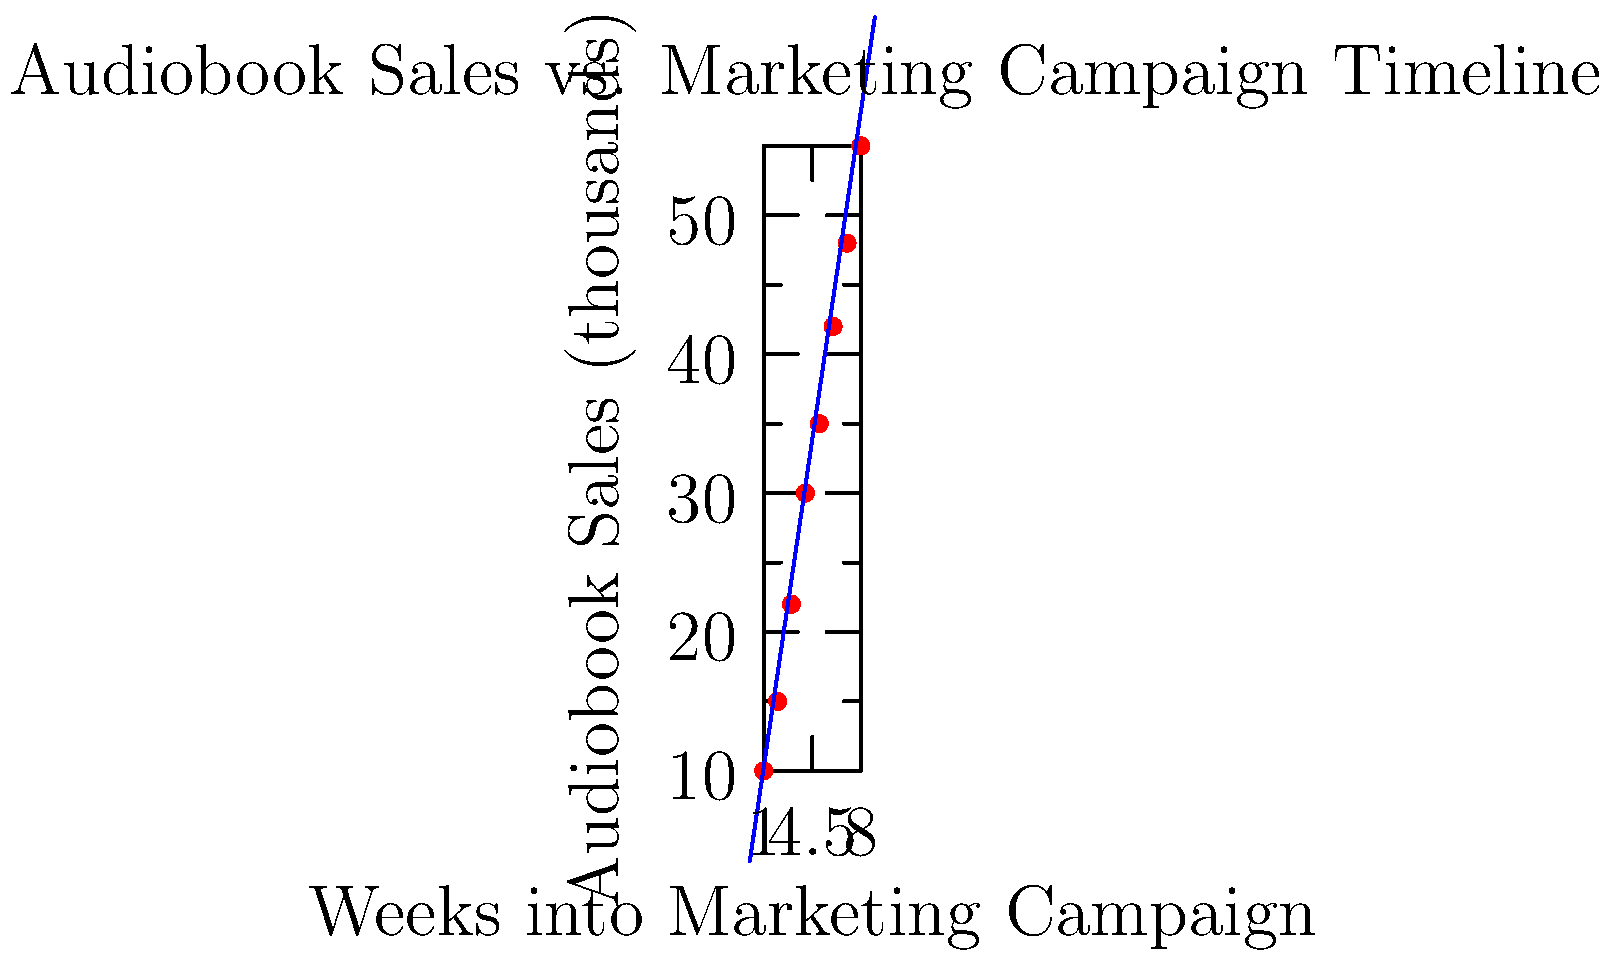Based on the scatter plot showing the relationship between audiobook sales and marketing campaign timeline, what can be inferred about the correlation between these two variables, and how might this information be used to enhance the marketability of audiobooks? To analyze the correlation between audiobook sales and marketing campaign timelines:

1. Observe the scatter plot: Points show a clear upward trend from left to right.

2. Identify the variables:
   - X-axis: Weeks into Marketing Campaign
   - Y-axis: Audiobook Sales (in thousands)

3. Assess the relationship:
   - As weeks progress, sales generally increase.
   - Points form a roughly linear pattern.
   - Positive correlation is evident.

4. Analyze the trend line:
   - Blue line represents the overall trend.
   - Slope is positive, confirming positive correlation.

5. Calculate correlation strength:
   - Use the formula: $r = \frac{\sum{(x_i - \bar{x})(y_i - \bar{y})}}{\sqrt{\sum{(x_i - \bar{x})^2}\sum{(y_i - \bar{y})^2}}}$
   - Result would be close to 1, indicating strong positive correlation.

6. Interpret for marketability:
   - Longer campaign duration correlates with higher sales.
   - Each week of campaign likely increases sales by about 6,750 units (slope of trend line).

7. Apply to marketing strategy:
   - Extend campaign duration for potentially higher sales.
   - Focus on consistent marketing efforts throughout the campaign.
   - Use sound design elements in marketing to maintain engagement over time.

8. Consider other factors:
   - Quality of marketing content
   - Target audience reach
   - Seasonal effects

This analysis provides insights for data-driven marketing decisions in audiobook promotion.
Answer: Strong positive correlation; extend marketing campaigns and use consistent, engaging sound design to potentially increase sales over time. 